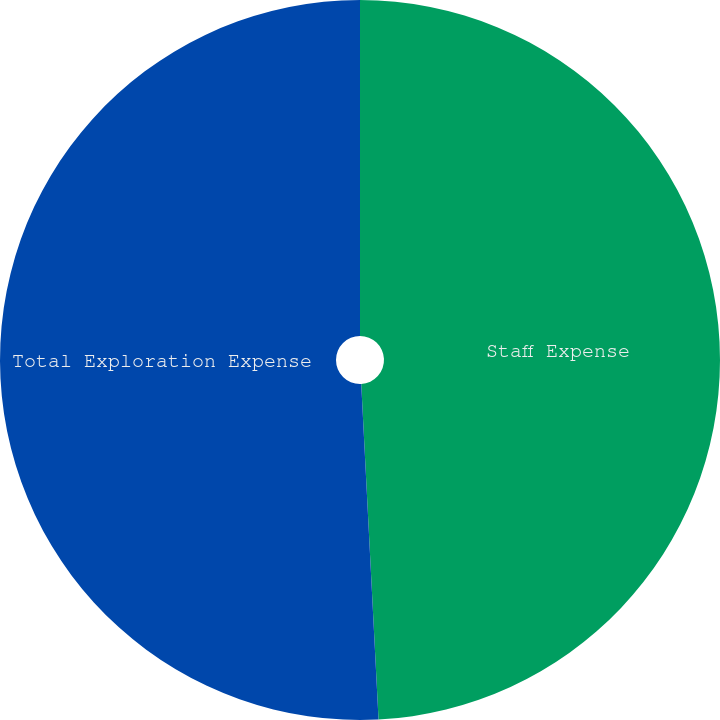<chart> <loc_0><loc_0><loc_500><loc_500><pie_chart><fcel>Staff Expense<fcel>Total Exploration Expense<nl><fcel>49.18%<fcel>50.82%<nl></chart> 